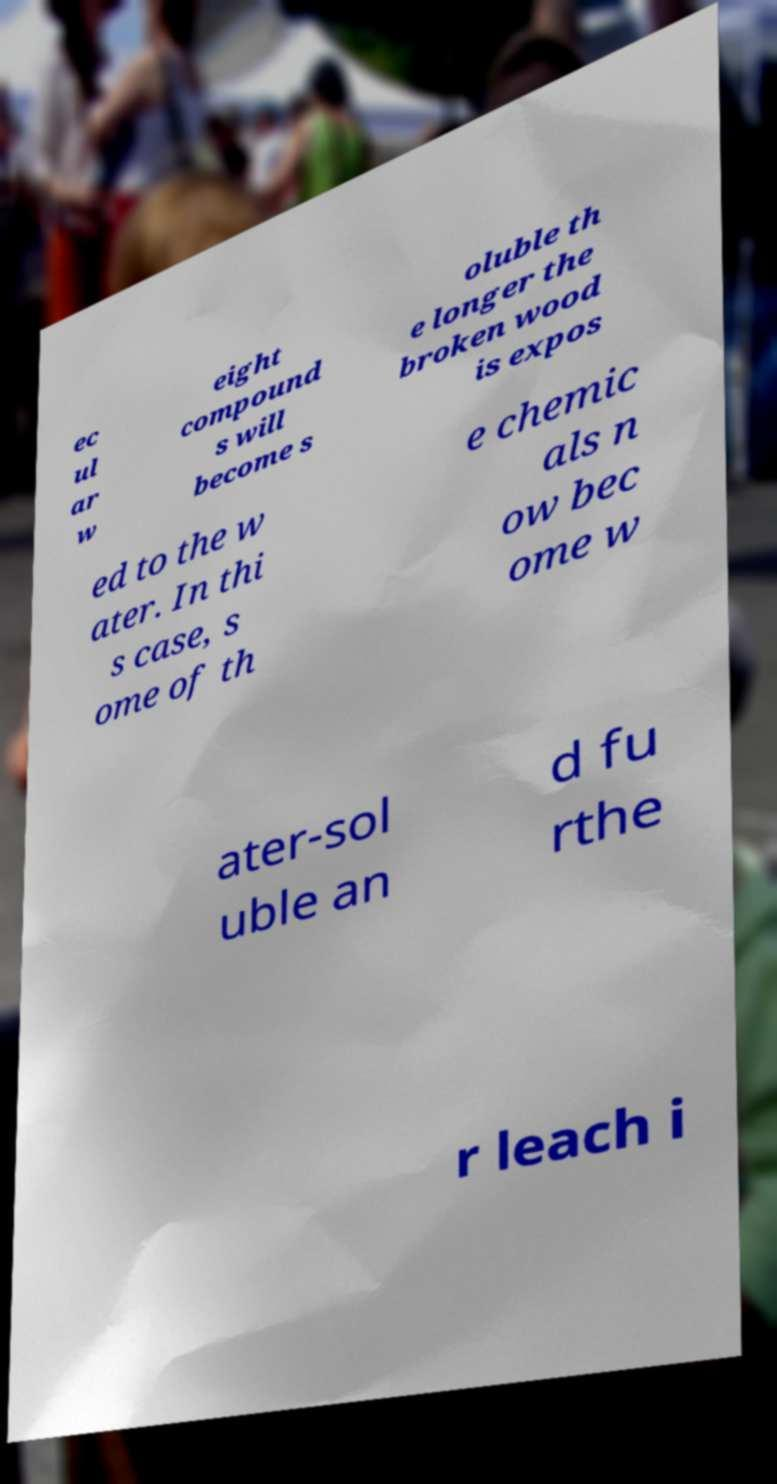Please identify and transcribe the text found in this image. ec ul ar w eight compound s will become s oluble th e longer the broken wood is expos ed to the w ater. In thi s case, s ome of th e chemic als n ow bec ome w ater-sol uble an d fu rthe r leach i 